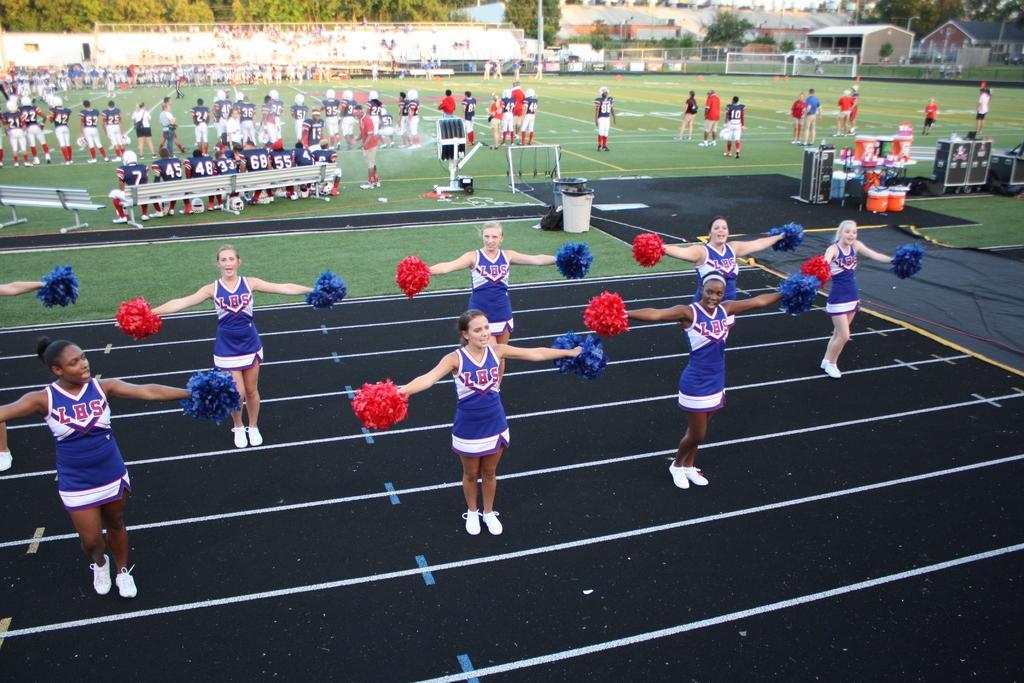In one or two sentences, can you explain what this image depicts? In this image there are women standing on the road. Right side there are devices and few objects. Left side there are benches on the grassland. People are sitting on the bench. There are people standing on the grassland. Right side there is a fence. Left side there is a wall. Background there are trees and buildings. There are dustbins on the grassland. Behind there are objects. 